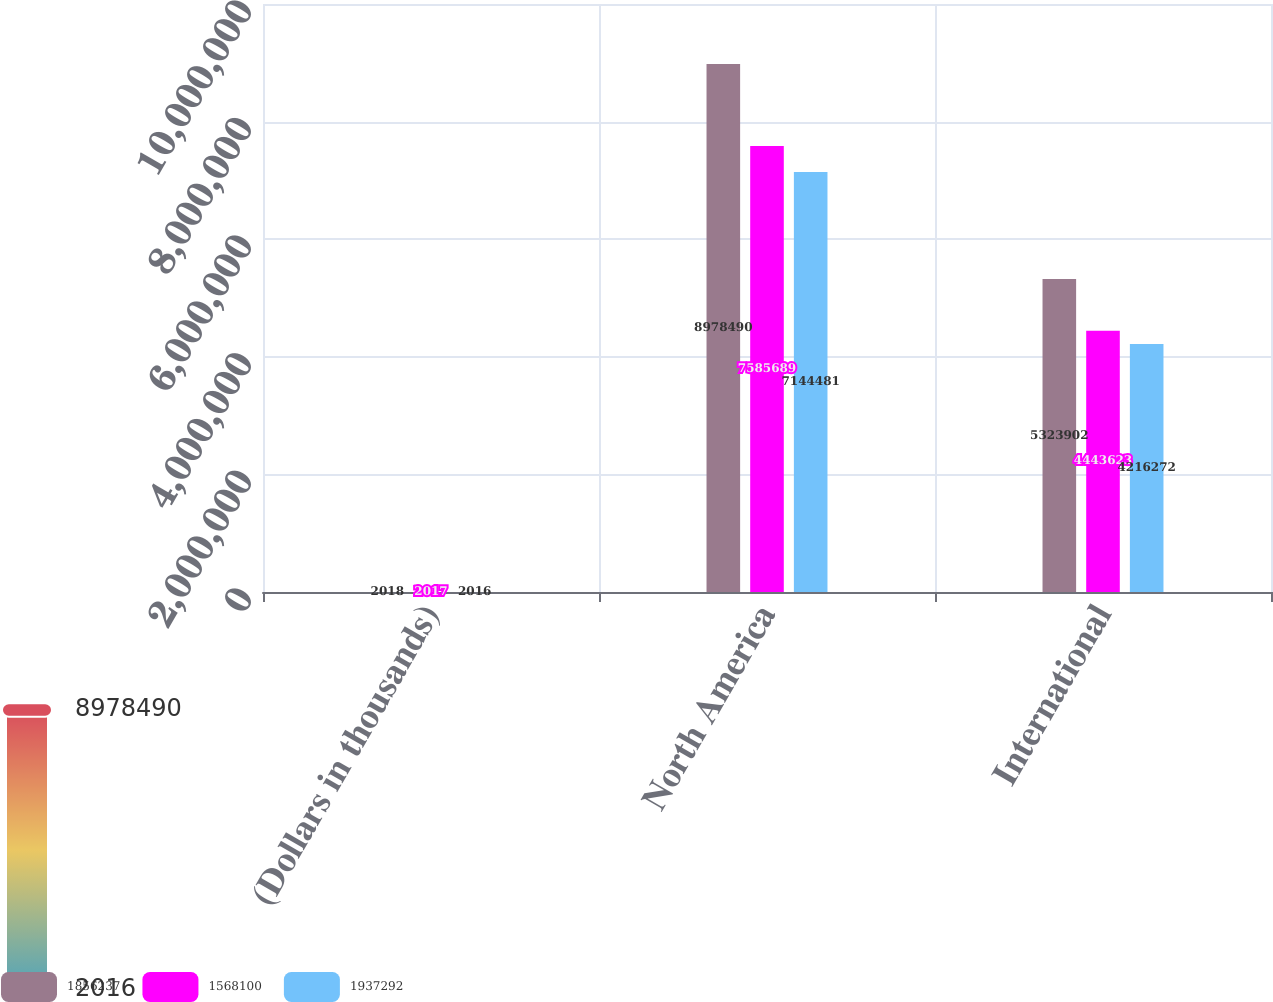Convert chart. <chart><loc_0><loc_0><loc_500><loc_500><stacked_bar_chart><ecel><fcel>(Dollars in thousands)<fcel>North America<fcel>International<nl><fcel>1.85624e+06<fcel>2018<fcel>8.97849e+06<fcel>5.3239e+06<nl><fcel>1.5681e+06<fcel>2017<fcel>7.58569e+06<fcel>4.44362e+06<nl><fcel>1.93729e+06<fcel>2016<fcel>7.14448e+06<fcel>4.21627e+06<nl></chart> 